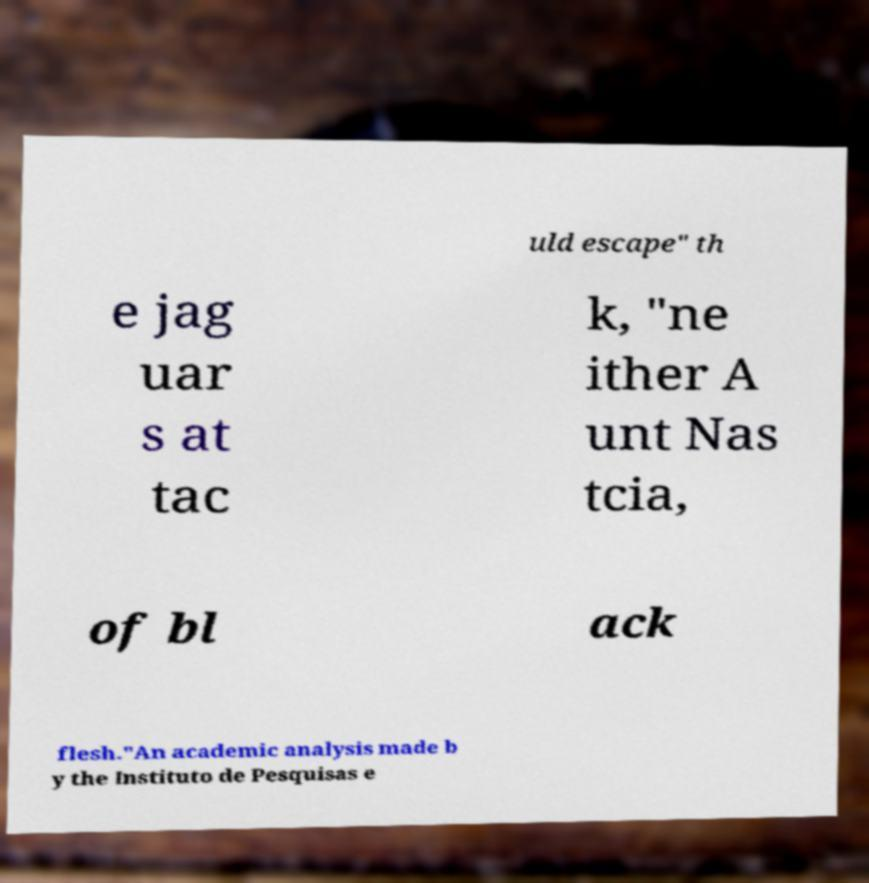There's text embedded in this image that I need extracted. Can you transcribe it verbatim? uld escape" th e jag uar s at tac k, "ne ither A unt Nas tcia, of bl ack flesh."An academic analysis made b y the Instituto de Pesquisas e 